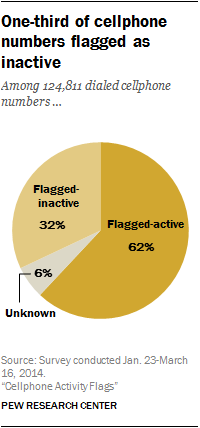Highlight a few significant elements in this photo. The value of Flagged active is greater than that of Flagged inactive. The least value represented in a pie chart is unknown. 